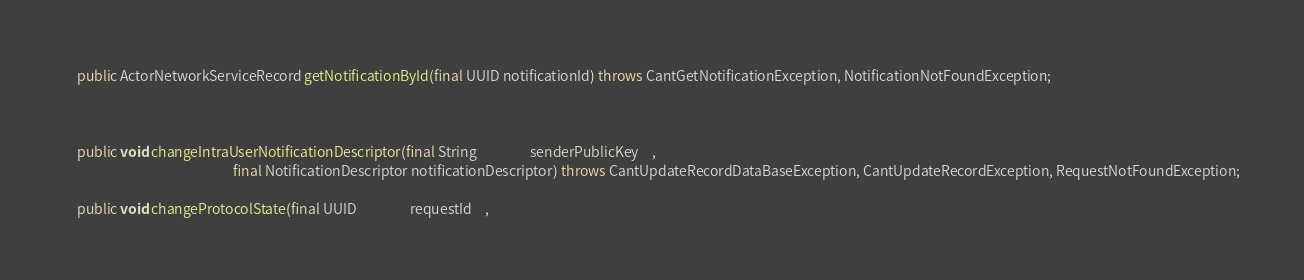Convert code to text. <code><loc_0><loc_0><loc_500><loc_500><_Java_>    public ActorNetworkServiceRecord getNotificationById(final UUID notificationId) throws CantGetNotificationException, NotificationNotFoundException;



    public void changeIntraUserNotificationDescriptor(final String                 senderPublicKey    ,
                                                      final NotificationDescriptor notificationDescriptor) throws CantUpdateRecordDataBaseException, CantUpdateRecordException, RequestNotFoundException;

    public void changeProtocolState(final UUID                 requestId    ,</code> 